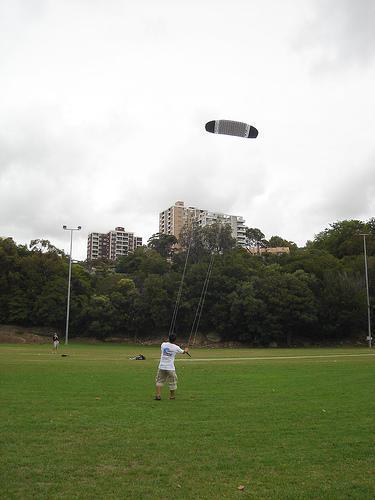How many street lights do you see?
Give a very brief answer. 2. 